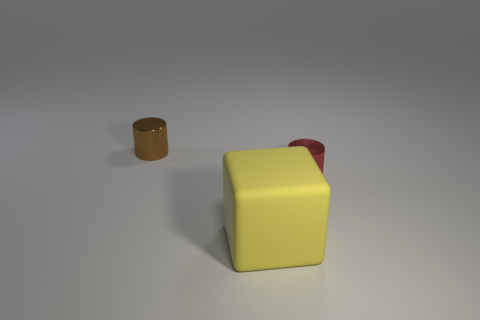Is the tiny red object made of the same material as the big yellow object?
Make the answer very short. No. How many small brown cylinders have the same material as the large cube?
Provide a short and direct response. 0. There is another small cylinder that is made of the same material as the small red cylinder; what color is it?
Provide a short and direct response. Brown. There is a large rubber thing; what shape is it?
Provide a short and direct response. Cube. What is the cylinder that is in front of the brown metallic cylinder made of?
Make the answer very short. Metal. There is another shiny object that is the same size as the red thing; what shape is it?
Your response must be concise. Cylinder. What color is the small object that is behind the tiny red cylinder?
Provide a succinct answer. Brown. Are there any tiny red metallic objects that are in front of the tiny thing to the left of the red cylinder?
Ensure brevity in your answer.  Yes. How many objects are tiny metallic cylinders on the right side of the big rubber thing or yellow metallic cylinders?
Offer a very short reply. 1. Is there any other thing that has the same size as the yellow matte cube?
Give a very brief answer. No. 